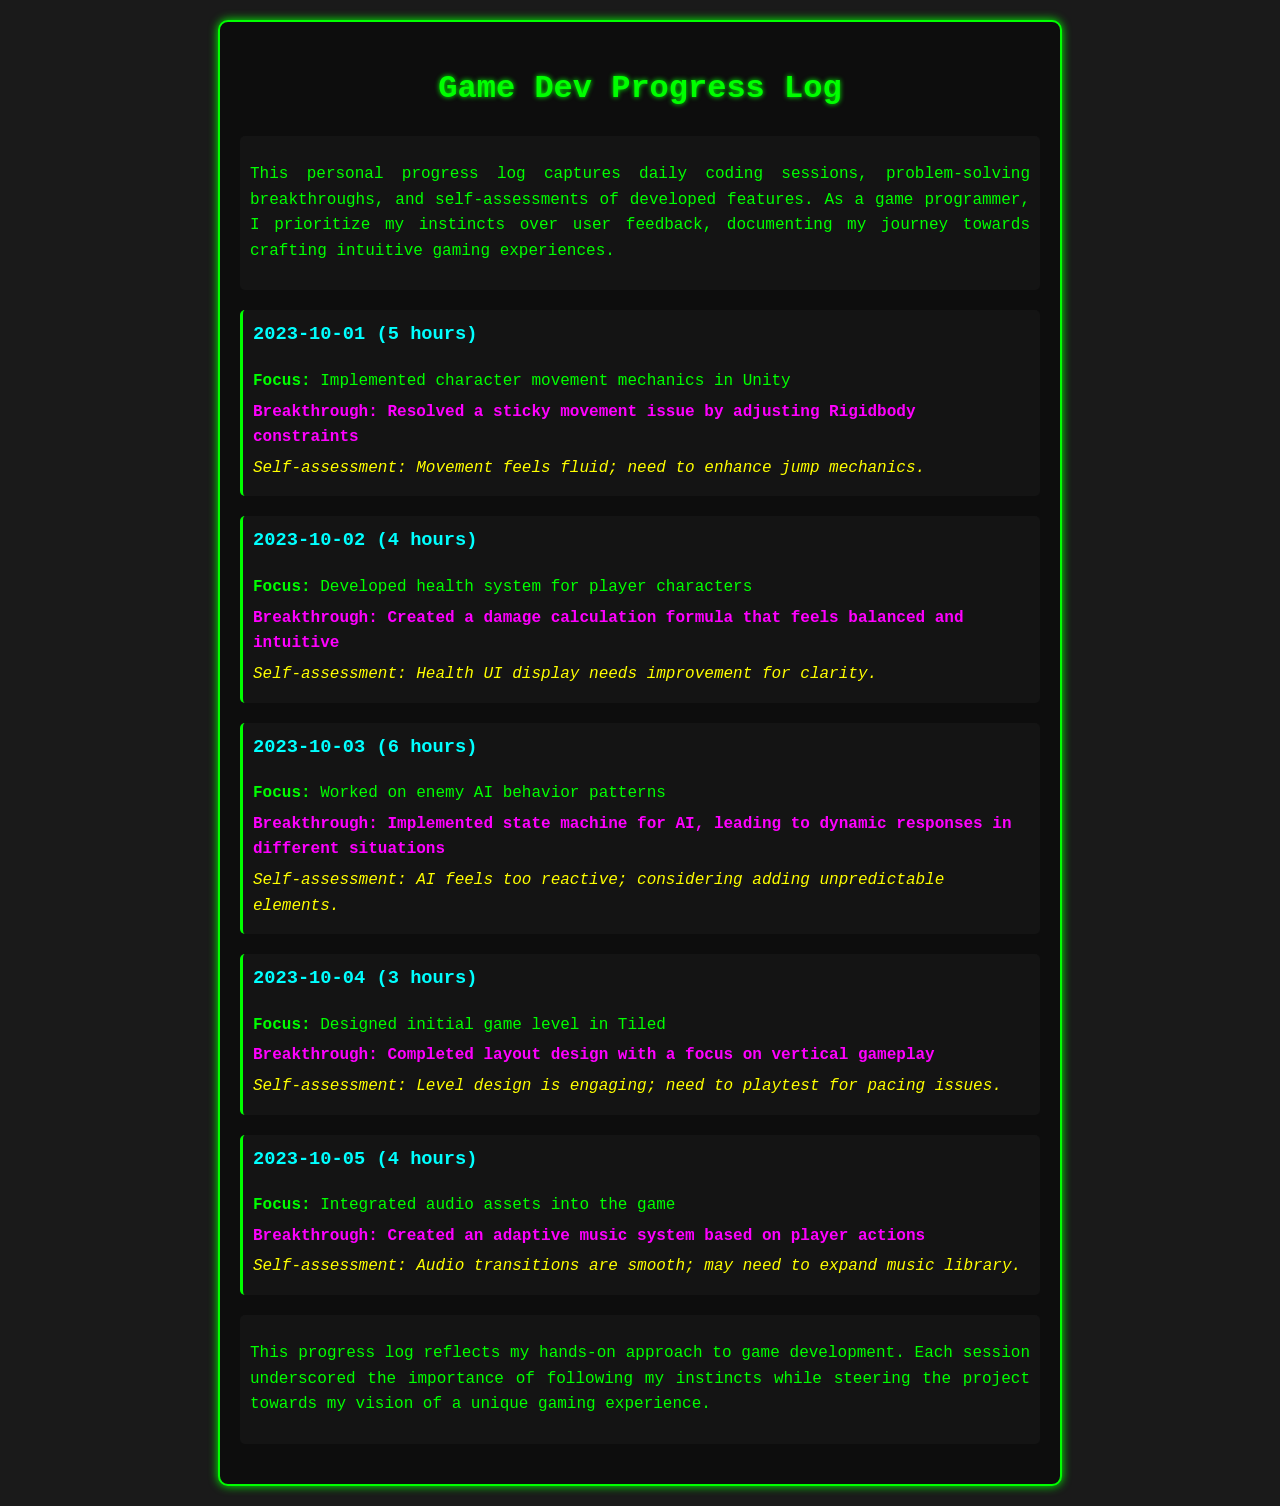What date did the character movement mechanics get implemented? The date mentioned for implementing character movement mechanics is provided in the session for October 1st.
Answer: 2023-10-01 How many hours were spent on developing the health system? The hours spent on developing the health system can be found in the session for October 2nd.
Answer: 4 hours What was the breakthrough achieved on October 3rd? The breakthrough for October 3rd is stated in the session focusing on enemy AI behavior patterns.
Answer: Implemented state machine for AI, leading to dynamic responses in different situations What is the self-assessment regarding the health UI display? The assessment for the health UI display is included in the self-assessment of the health system development session.
Answer: Needs improvement for clarity How many sessions are documented in total? To find the total number of sessions, count each individual session listed in the document.
Answer: 5 sessions What aspect of the audio integration was highlighted as a breakthrough? The specific breakthrough in audio integration is described in the session discussing it on October 5th.
Answer: Created an adaptive music system based on player actions Which date focuses on designing the initial game level? The date for the initial game level design is found in the corresponding session discussing Tiled.
Answer: 2023-10-04 What is the overarching theme of the progress log? The introduction of the log provides insight into the overall theme and intent behind documenting progress.
Answer: Captures daily coding sessions, problem-solving breakthroughs, and self-assessments of developed features 